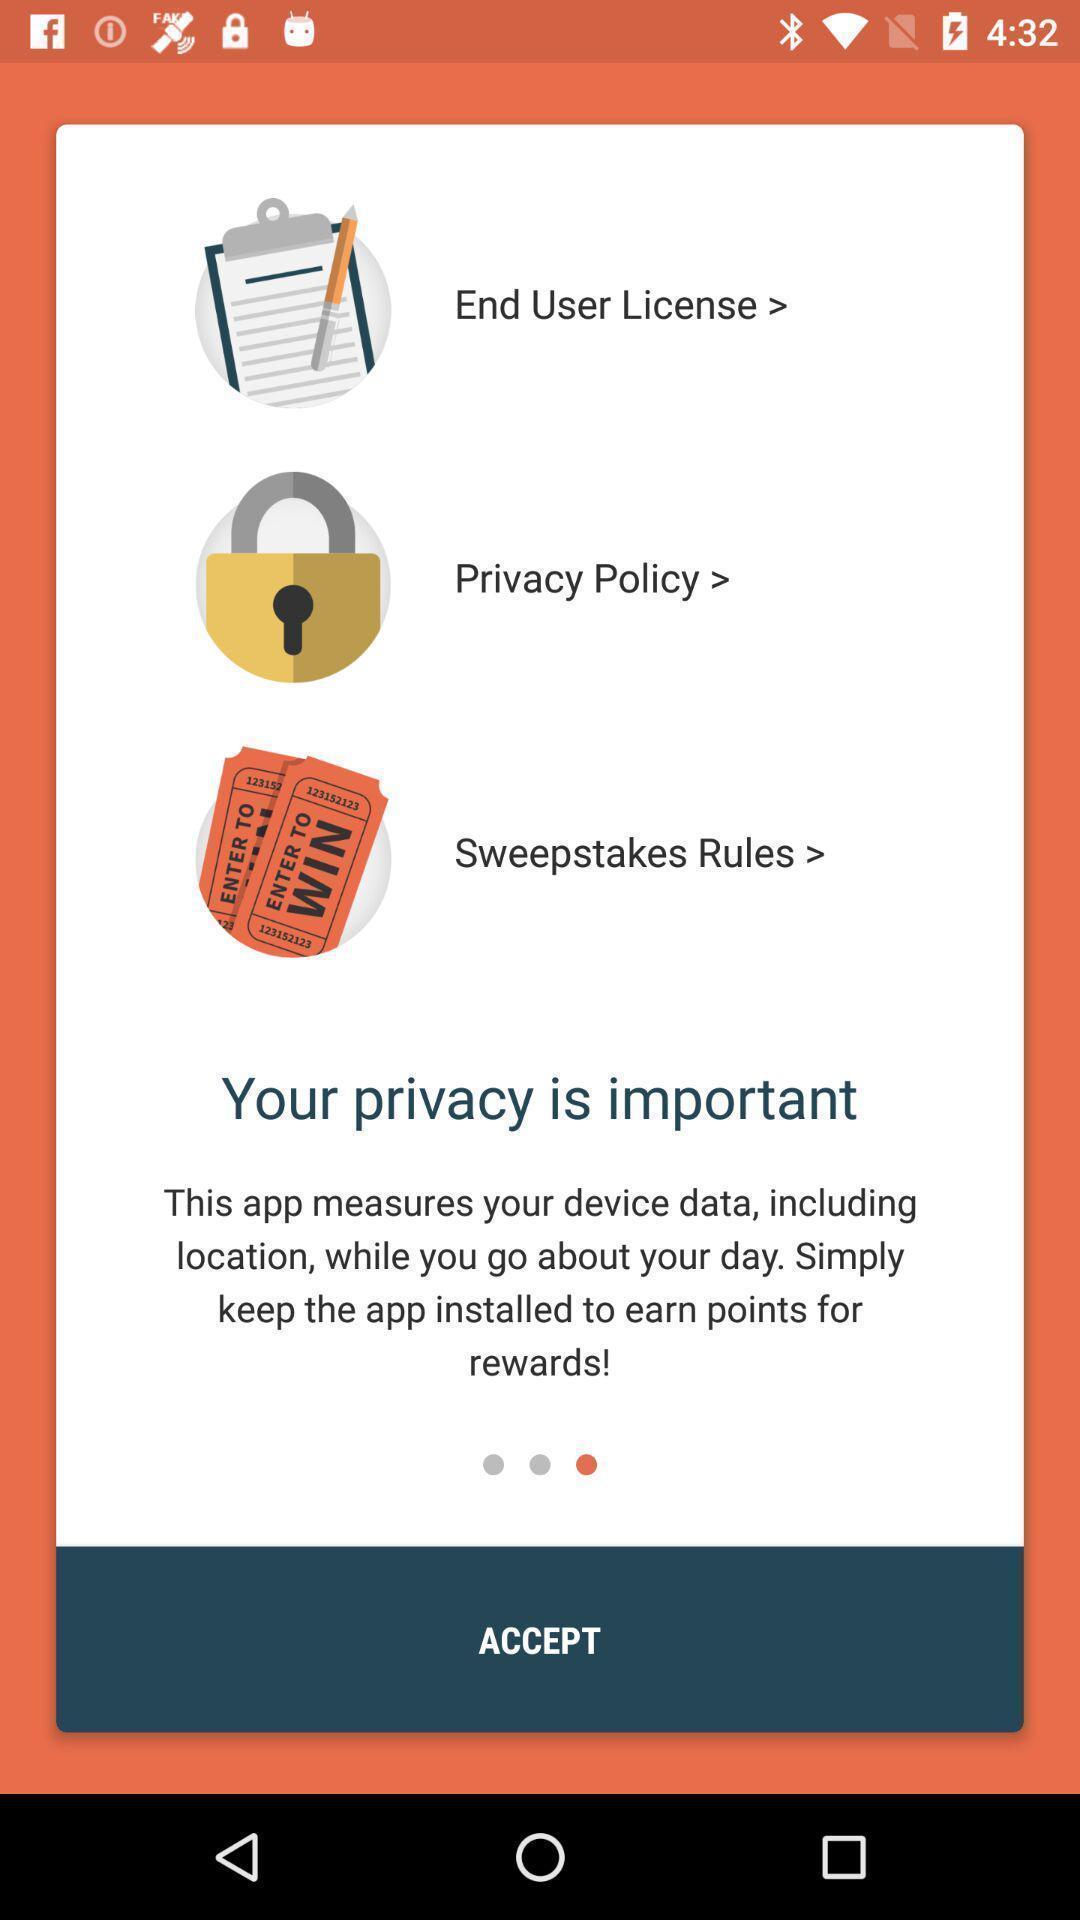Describe the key features of this screenshot. Screen asking to accept the terms and conditions. 